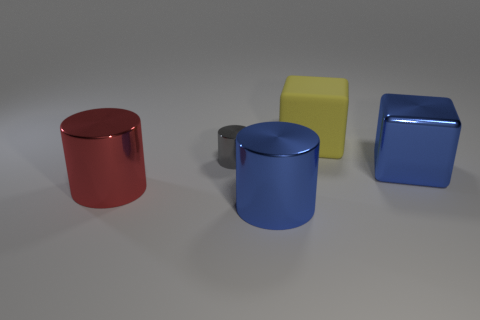What material is the big cylinder that is the same color as the metallic cube?
Your answer should be compact. Metal. Are there any blue shiny objects that have the same shape as the large rubber object?
Ensure brevity in your answer.  Yes. There is a blue metallic object to the left of the big yellow rubber thing; what is its size?
Your answer should be very brief. Large. There is a red cylinder that is the same size as the yellow rubber thing; what material is it?
Make the answer very short. Metal. Is the number of large blue things greater than the number of large blue cylinders?
Your answer should be compact. Yes. What is the size of the blue object that is behind the metallic object that is to the left of the tiny gray object?
Offer a very short reply. Large. There is a yellow matte object that is the same size as the red object; what shape is it?
Your response must be concise. Cube. What is the shape of the blue thing in front of the large blue object behind the big object that is in front of the large red thing?
Provide a succinct answer. Cylinder. There is a object behind the tiny gray metal object; does it have the same color as the large metal cylinder on the right side of the tiny metallic cylinder?
Keep it short and to the point. No. What number of small shiny cylinders are there?
Give a very brief answer. 1. 